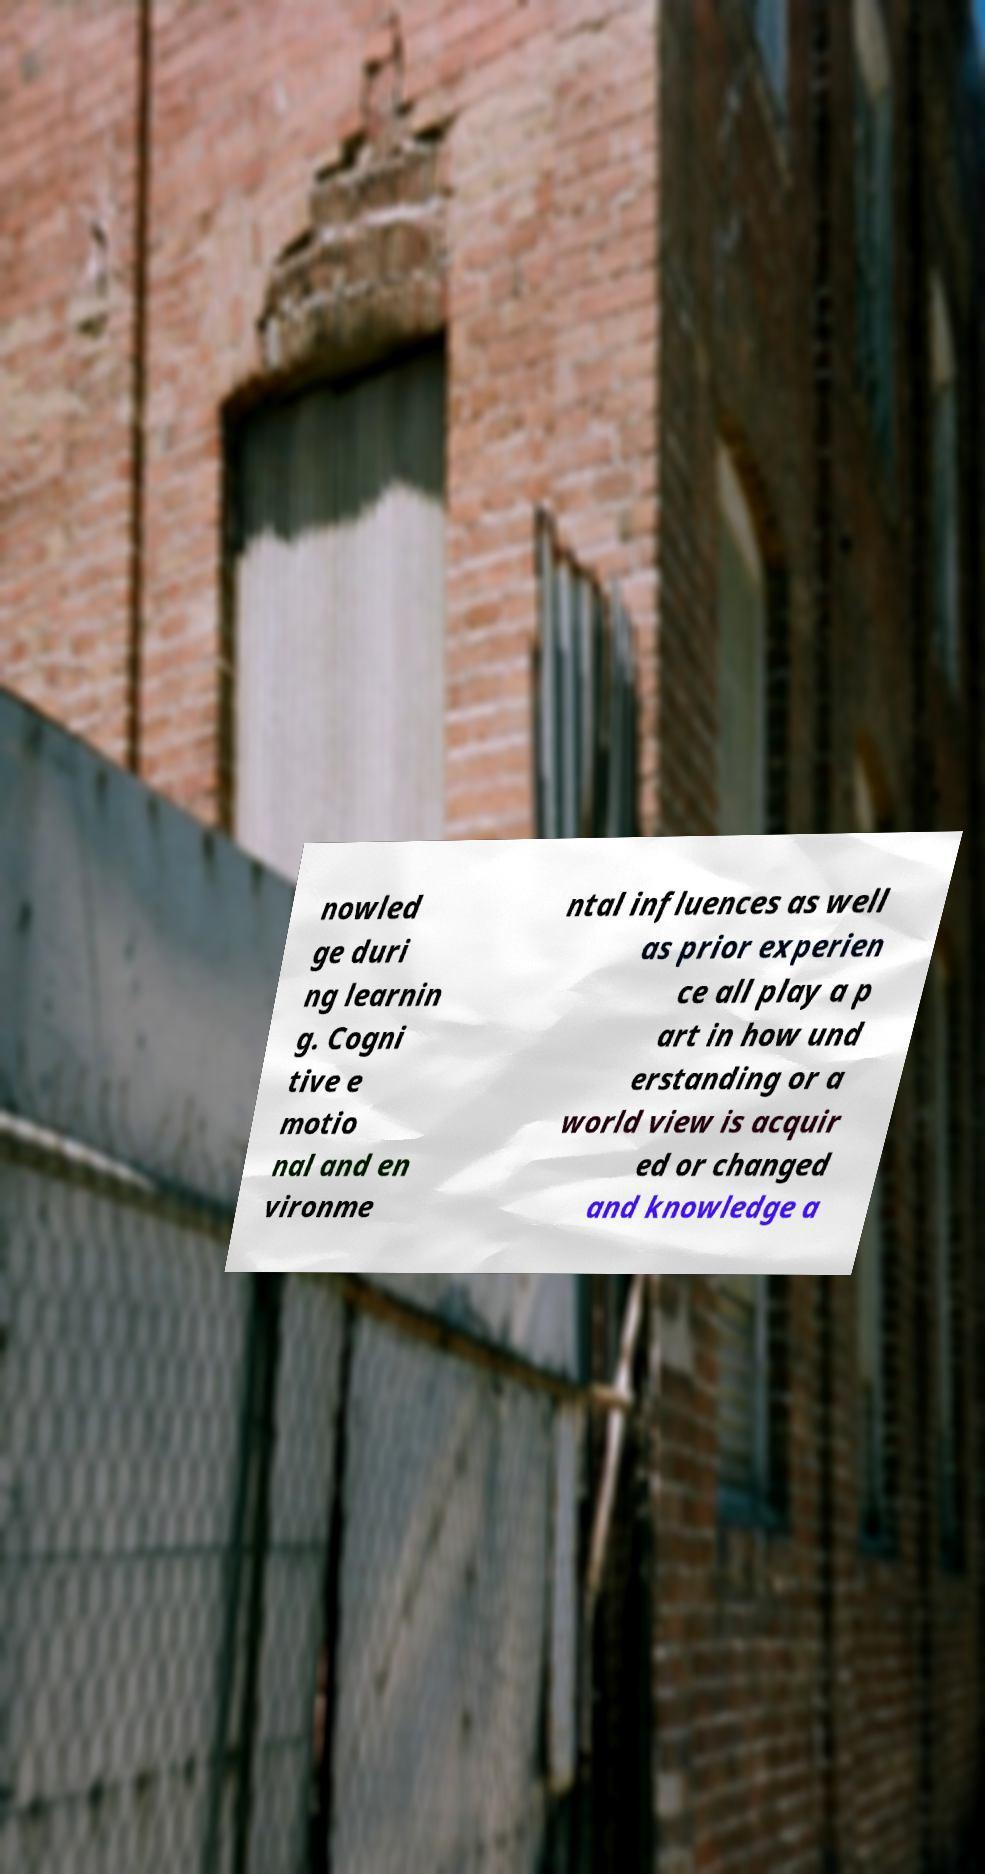Please identify and transcribe the text found in this image. nowled ge duri ng learnin g. Cogni tive e motio nal and en vironme ntal influences as well as prior experien ce all play a p art in how und erstanding or a world view is acquir ed or changed and knowledge a 